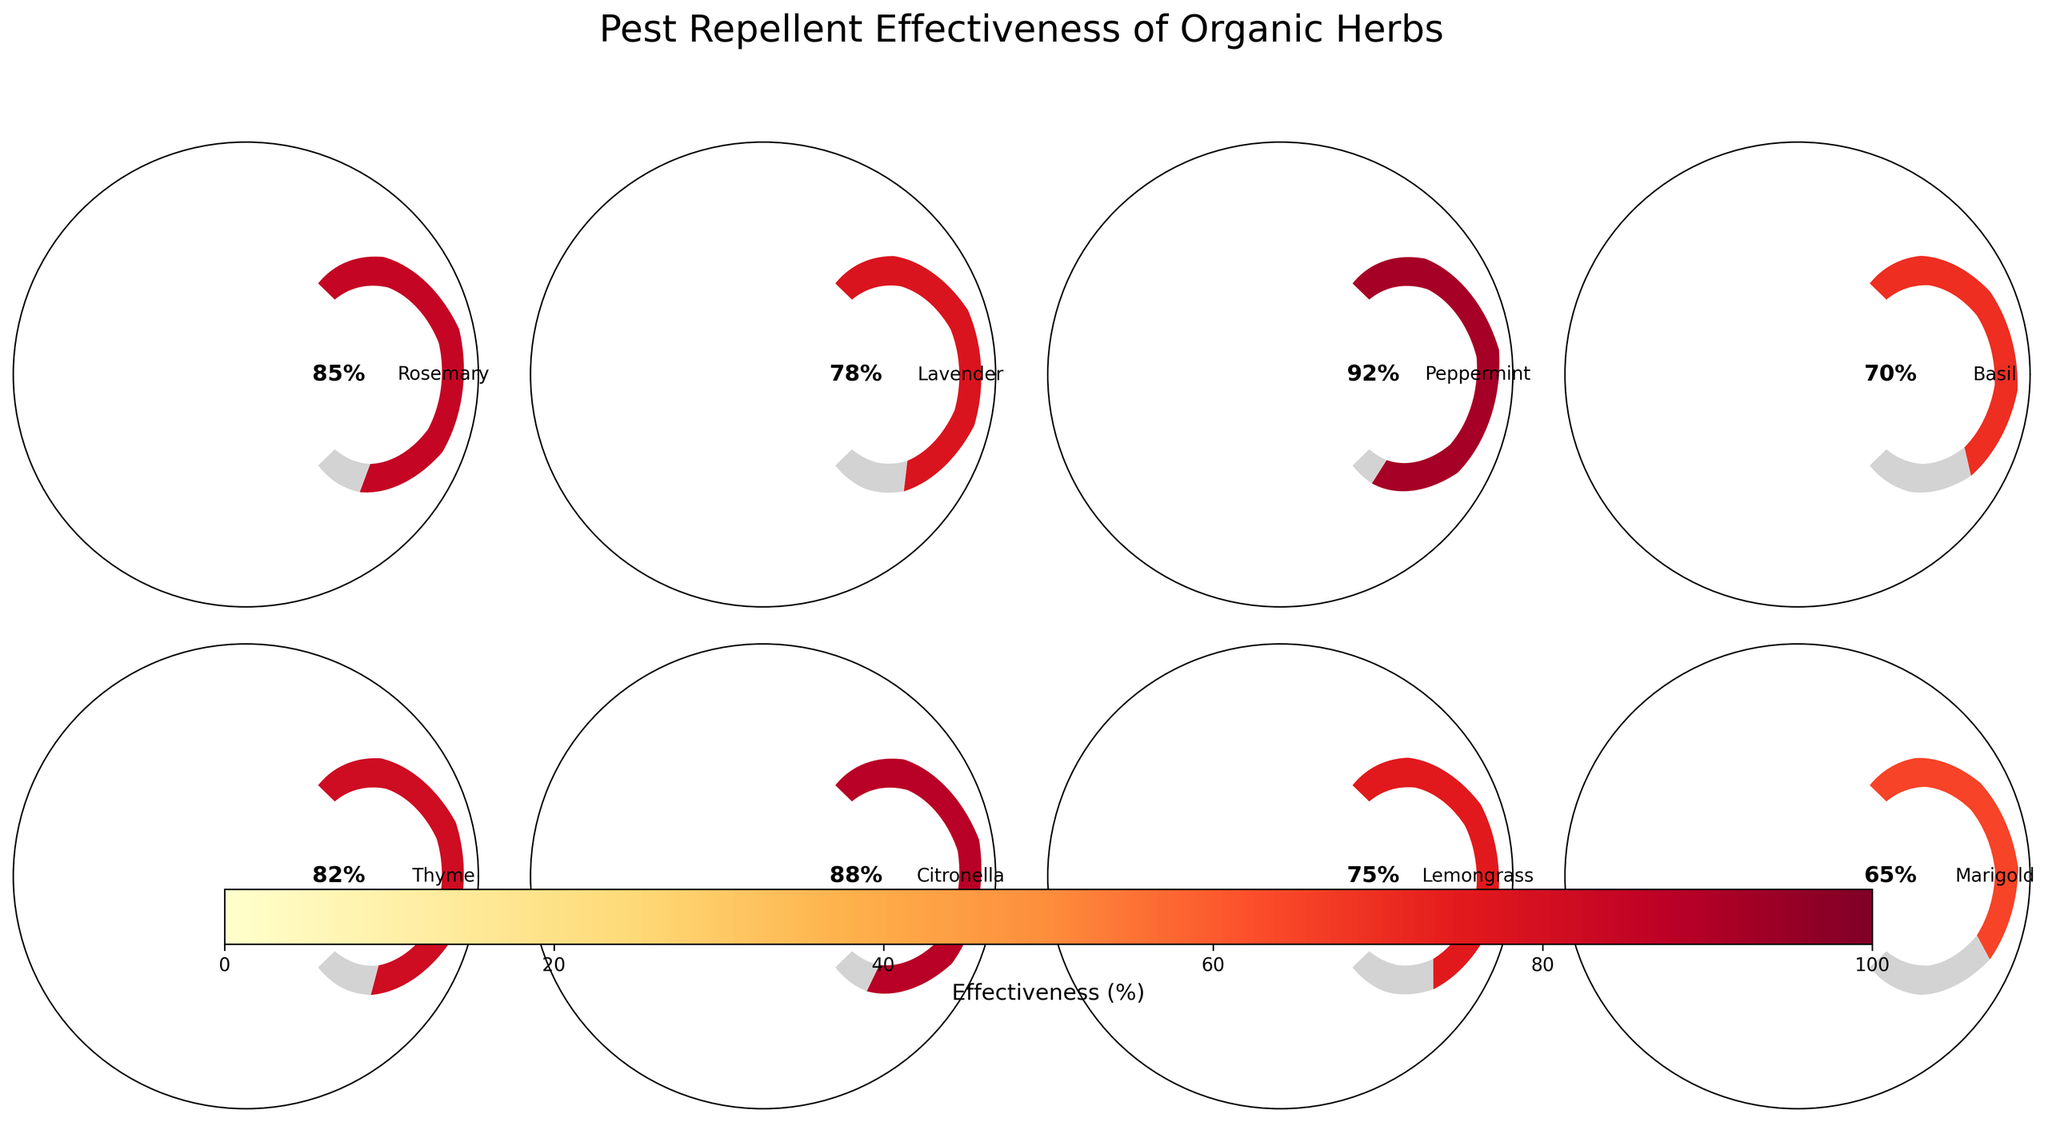What's the title of the figure? The title of a figure is usually found above it and usually in larger or bold text. In this case, the title is "Pest Repellent Effectiveness of Organic Herbs" positioned at the top center of the chart.
Answer: Pest Repellent Effectiveness of Organic Herbs Which herb has the highest pest repellent effectiveness? To find the highest effectiveness, we look at the gauge charts and identify the herb with the needle pointing to the highest percentage. Peppermint has the highest effectiveness at 92%.
Answer: Peppermint How many herbs have an effectiveness rating above 80%? We count the number of herbs with effectiveness ratings above 80%. Rosemary (85), Peppermint (92), Thyme (82), and Citronella (88) are above this threshold. The total number is 4.
Answer: 4 What is the average effectiveness of the herbs? To compute the average effectiveness, sum the effectiveness values for all herbs and divide by the number of herbs: (85 + 78 + 92 + 70 + 82 + 88 + 75 + 65)/8 = 80.625.
Answer: 80.625 Which herb has the lowest pest repellent effectiveness? To find the lowest effectiveness, we look for the herb with the needle pointing to the lowest percentage. Marigold shows the lowest effectiveness at 65%.
Answer: Marigold Which two herbs have the most similar effectiveness ratings? We compare the effectiveness ratings and find the closest values. Lemongrass (75) and Lavender (78) have a difference of 3 percentage points, which is the smallest difference among all herbs.
Answer: Lemongrass and Lavender What is the effectiveness difference between Basil and Citronella? To find the difference, subtract the effectiveness of Basil (70) from Citronella (88). The difference is 18.
Answer: 18 Which herb has a pest repellent effectiveness closest to 80%? We look for the effectiveness rating closest to 80%. Both Lavender and Thyme are close, but Thyme at 82% is closest.
Answer: Thyme What is the range of the effectiveness ratings shown in the chart? The range is found by subtracting the lowest rating from the highest rating. The highest is Peppermint at 92% and the lowest is Marigold at 65%. The range is 92 - 65 = 27.
Answer: 27 How does the color of the gauge chart correspond to the effectiveness rating? The color indicates the effectiveness percentage, where the colormap shifts from lighter shades for lower effectiveness to darker shades for higher effectiveness.
Answer: Light to dark shades represent low to high effectiveness 